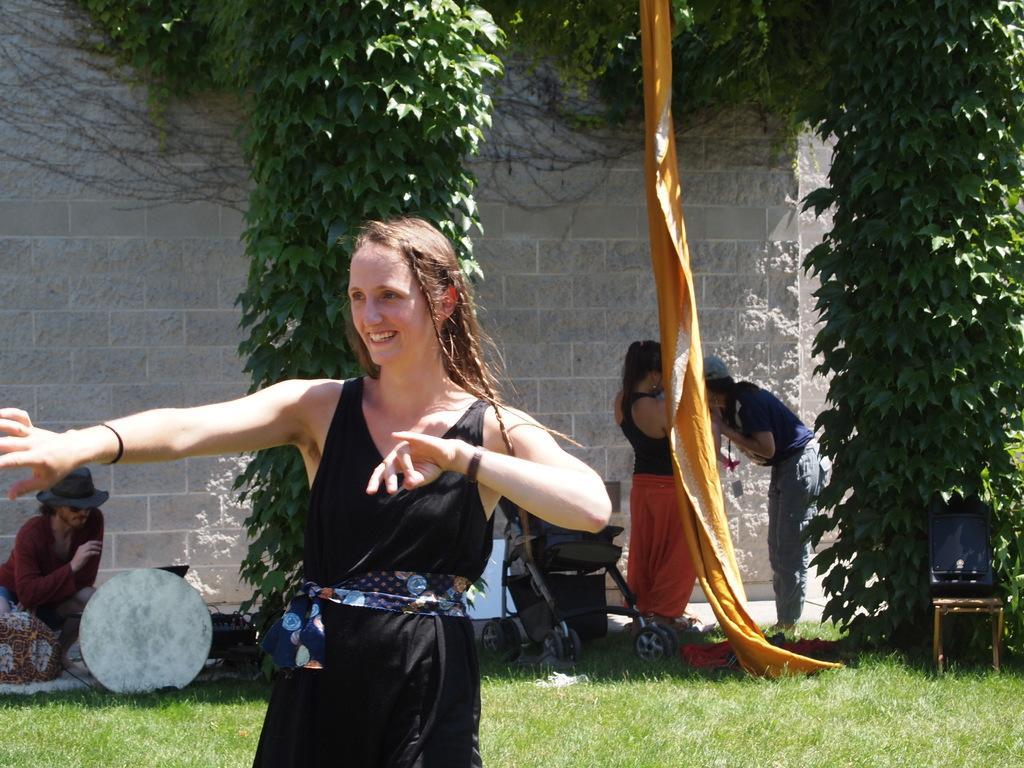Can you describe this image briefly? In this picture we can see a woman in the black dress is dancing and on the left side of the woman there is a person sitting and on the right side of the woman there are two people standing. Behind the woman there is a stroller, chair, trees, a wall and other objects. 